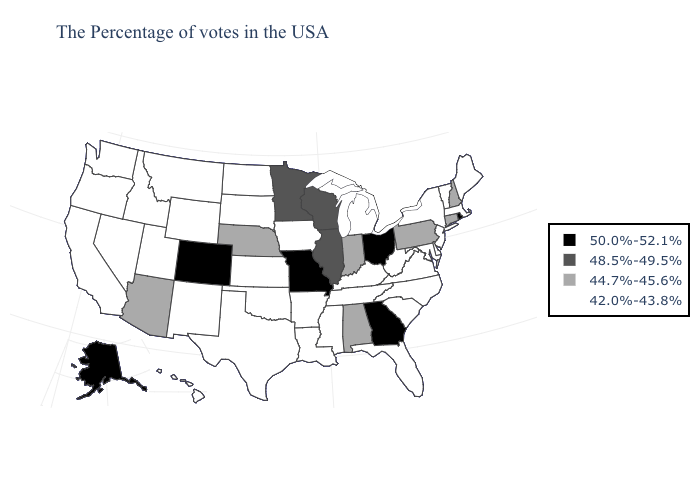Among the states that border Oregon , which have the lowest value?
Keep it brief. Idaho, Nevada, California, Washington. Does Idaho have the same value as Virginia?
Be succinct. Yes. What is the lowest value in states that border Oklahoma?
Be succinct. 42.0%-43.8%. Does Oregon have a lower value than Iowa?
Be succinct. No. Does Rhode Island have the highest value in the Northeast?
Answer briefly. Yes. What is the value of Oklahoma?
Short answer required. 42.0%-43.8%. Does Rhode Island have the highest value in the Northeast?
Write a very short answer. Yes. What is the value of New Hampshire?
Answer briefly. 44.7%-45.6%. What is the value of Maine?
Answer briefly. 42.0%-43.8%. Which states have the lowest value in the USA?
Give a very brief answer. Maine, Massachusetts, Vermont, New York, New Jersey, Delaware, Maryland, Virginia, North Carolina, South Carolina, West Virginia, Florida, Michigan, Kentucky, Tennessee, Mississippi, Louisiana, Arkansas, Iowa, Kansas, Oklahoma, Texas, South Dakota, North Dakota, Wyoming, New Mexico, Utah, Montana, Idaho, Nevada, California, Washington, Oregon, Hawaii. Name the states that have a value in the range 44.7%-45.6%?
Quick response, please. New Hampshire, Connecticut, Pennsylvania, Indiana, Alabama, Nebraska, Arizona. Name the states that have a value in the range 42.0%-43.8%?
Quick response, please. Maine, Massachusetts, Vermont, New York, New Jersey, Delaware, Maryland, Virginia, North Carolina, South Carolina, West Virginia, Florida, Michigan, Kentucky, Tennessee, Mississippi, Louisiana, Arkansas, Iowa, Kansas, Oklahoma, Texas, South Dakota, North Dakota, Wyoming, New Mexico, Utah, Montana, Idaho, Nevada, California, Washington, Oregon, Hawaii. Is the legend a continuous bar?
Write a very short answer. No. Name the states that have a value in the range 48.5%-49.5%?
Quick response, please. Wisconsin, Illinois, Minnesota. Which states have the lowest value in the USA?
Concise answer only. Maine, Massachusetts, Vermont, New York, New Jersey, Delaware, Maryland, Virginia, North Carolina, South Carolina, West Virginia, Florida, Michigan, Kentucky, Tennessee, Mississippi, Louisiana, Arkansas, Iowa, Kansas, Oklahoma, Texas, South Dakota, North Dakota, Wyoming, New Mexico, Utah, Montana, Idaho, Nevada, California, Washington, Oregon, Hawaii. 